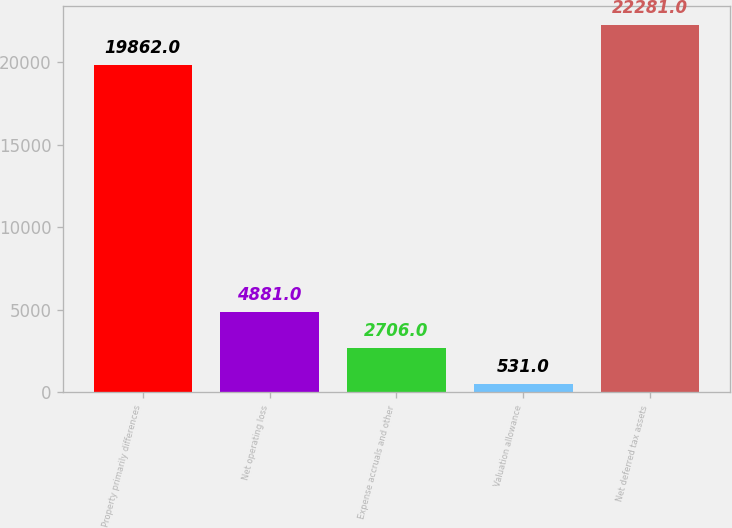Convert chart. <chart><loc_0><loc_0><loc_500><loc_500><bar_chart><fcel>Property primarily differences<fcel>Net operating loss<fcel>Expense accruals and other<fcel>Valuation allowance<fcel>Net deferred tax assets<nl><fcel>19862<fcel>4881<fcel>2706<fcel>531<fcel>22281<nl></chart> 